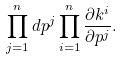<formula> <loc_0><loc_0><loc_500><loc_500>\prod ^ { n } _ { j = 1 } d p ^ { j } \prod ^ { n } _ { i = 1 } \frac { \partial k ^ { i } } { \partial p ^ { j } } .</formula> 